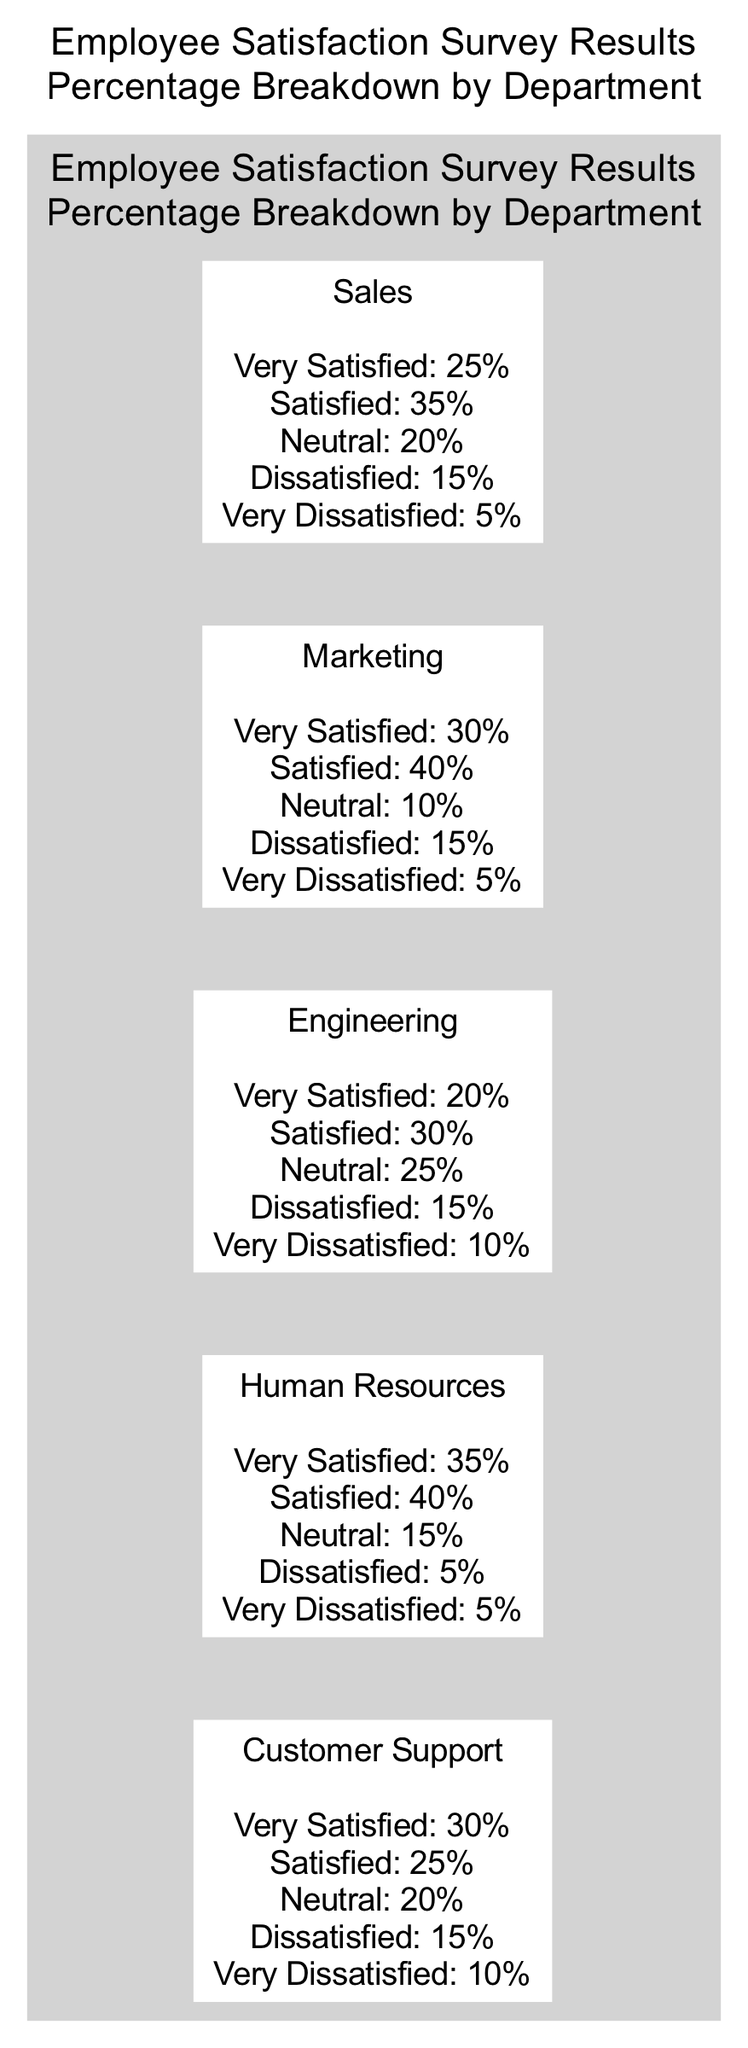What percentage of Sales department employees are very satisfied? The diagram specifies the percentage breakdown for the Sales department. It indicates that 25% of employees in the Sales department are categorized as very satisfied.
Answer: 25% Which department has the highest percentage of satisfied employees? By analyzing the satisfaction percentages for each department, Marketing has the highest percentage of satisfied employees at 40% (35% satisfied + 30% very satisfied).
Answer: Marketing How many departments report a neutral satisfaction percentage of 20%? The diagram presents the satisfaction breakdown for each department. Only the Customer Support department has a neutral satisfaction percentage of 20%.
Answer: 1 What is the percentage of very dissatisfied employees in the Engineering department? The Engineering department's satisfaction breakdown shows that 10% of employees are very dissatisfied.
Answer: 10% Which department has both the lowest percentage of dissatisfied and very dissatisfied employees combined? Evaluating the dissatisfaction percentages, the Human Resources department only has 5% dissatisfied and 5% very dissatisfied, totaling 10%. This is the lowest combined percentage compared to other departments.
Answer: Human Resources What is the overall satisfaction percentage for the Human Resources department? By summing the percentages of the very satisfied (35%) and satisfied (40%) employees, the overall satisfaction for Human Resources is 75%.
Answer: 75% Which department experiences the highest dissatisfaction rate? The Engineering department has a combined dissatisfaction rate of 25% (15% dissatisfied + 10% very dissatisfied), which is the highest among all departments.
Answer: Engineering What percentage of customers are neutral in the Customer Support department? The diagram reveals that in the Customer Support department, 20% of employees are classified as neutral.
Answer: 20% 